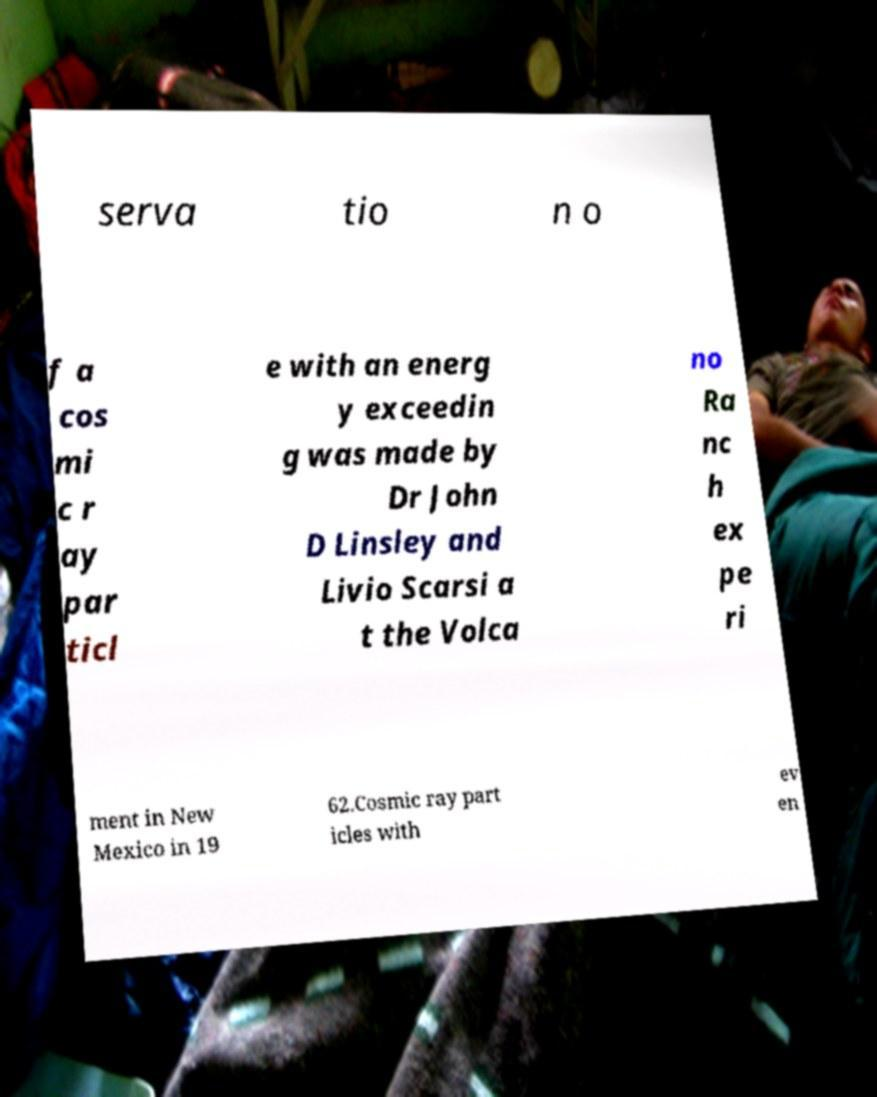Could you assist in decoding the text presented in this image and type it out clearly? serva tio n o f a cos mi c r ay par ticl e with an energ y exceedin g was made by Dr John D Linsley and Livio Scarsi a t the Volca no Ra nc h ex pe ri ment in New Mexico in 19 62.Cosmic ray part icles with ev en 